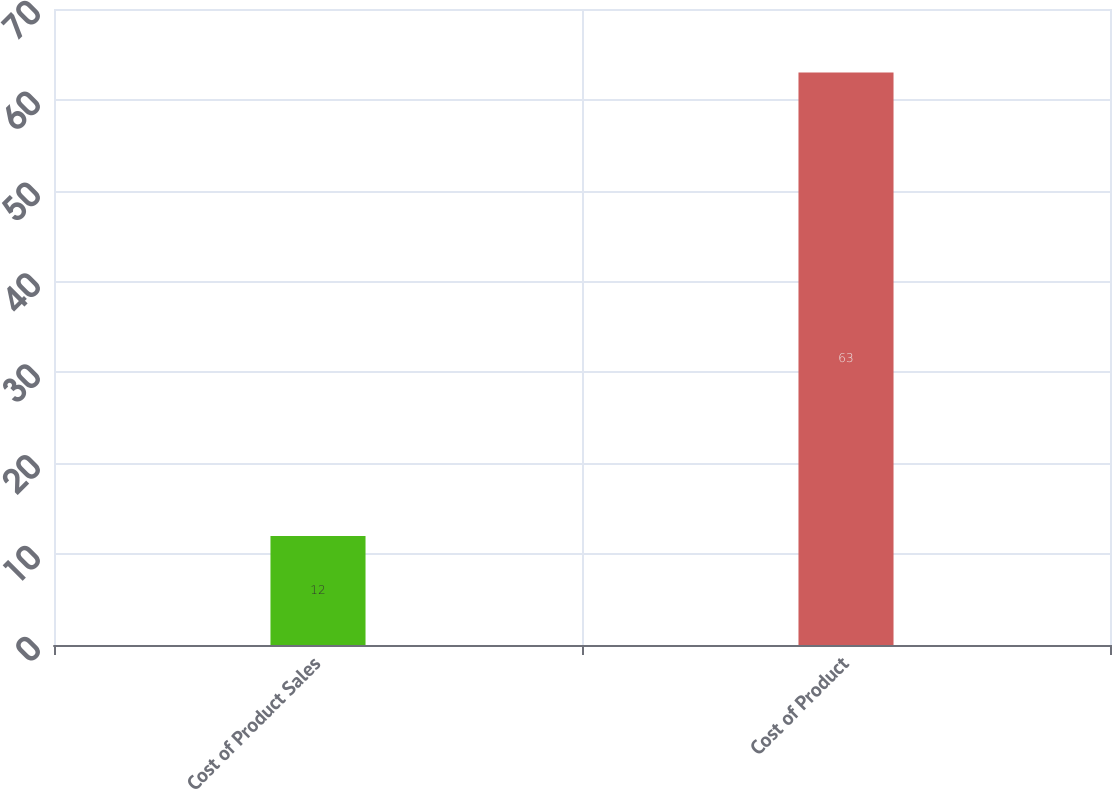Convert chart. <chart><loc_0><loc_0><loc_500><loc_500><bar_chart><fcel>Cost of Product Sales<fcel>Cost of Product<nl><fcel>12<fcel>63<nl></chart> 